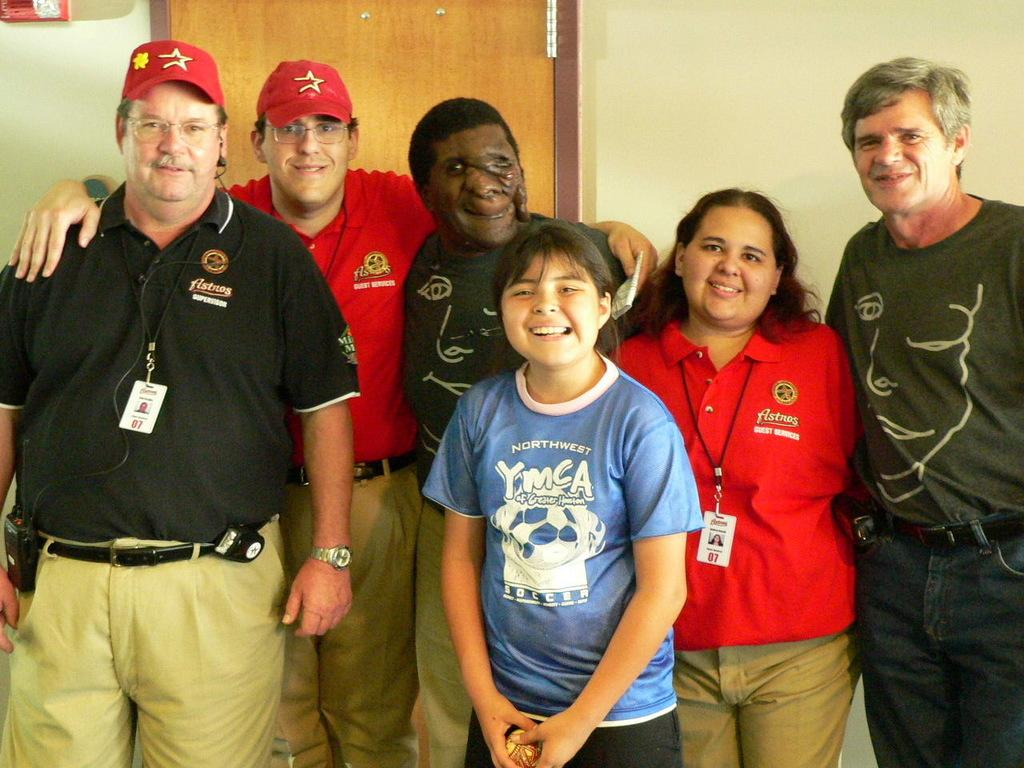How many people are in the image? There are six people in the image, four men and two women. What are the people in the image doing? The people are posing for a photograph. What can be seen in the background of the image? There is a wall in the background of the image, and there is a door on the wall. What type of hammer is being used by one of the men in the image? There is no hammer present in the image; the people are posing for a photograph. 